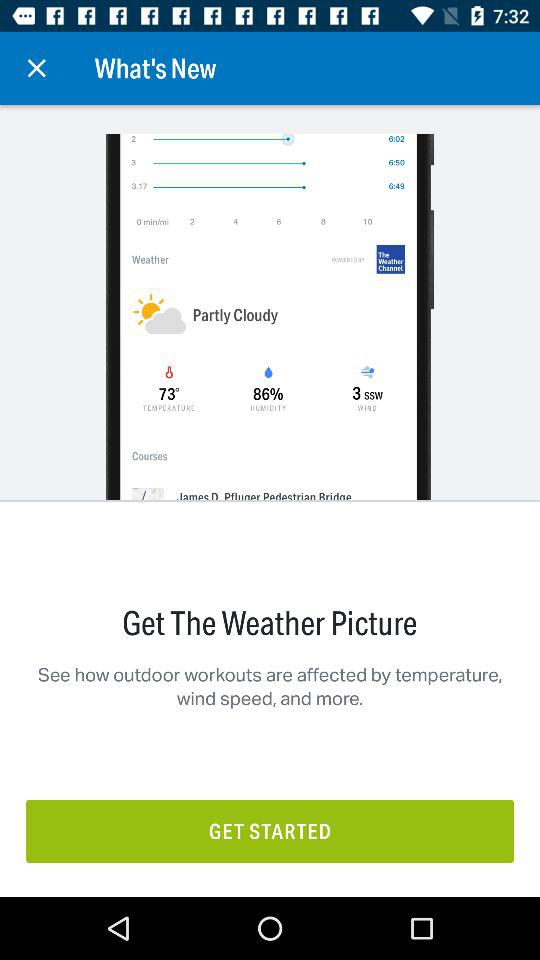What is the wind speed? The wind speed is "3 SSW". 